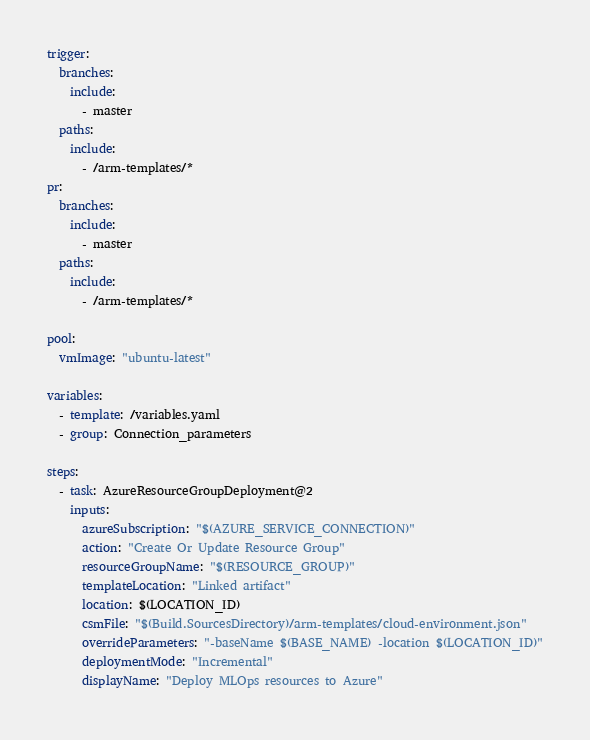Convert code to text. <code><loc_0><loc_0><loc_500><loc_500><_YAML_>trigger:
  branches:
    include:
      - master
  paths:
    include:
      - /arm-templates/*
pr:
  branches:
    include:
      - master
  paths:
    include:
      - /arm-templates/*

pool:
  vmImage: "ubuntu-latest"

variables:
  - template: /variables.yaml
  - group: Connection_parameters

steps:
  - task: AzureResourceGroupDeployment@2
    inputs:
      azureSubscription: "$(AZURE_SERVICE_CONNECTION)"
      action: "Create Or Update Resource Group"
      resourceGroupName: "$(RESOURCE_GROUP)"
      templateLocation: "Linked artifact"
      location: $(LOCATION_ID)
      csmFile: "$(Build.SourcesDirectory)/arm-templates/cloud-environment.json"
      overrideParameters: "-baseName $(BASE_NAME) -location $(LOCATION_ID)"
      deploymentMode: "Incremental"
      displayName: "Deploy MLOps resources to Azure"</code> 